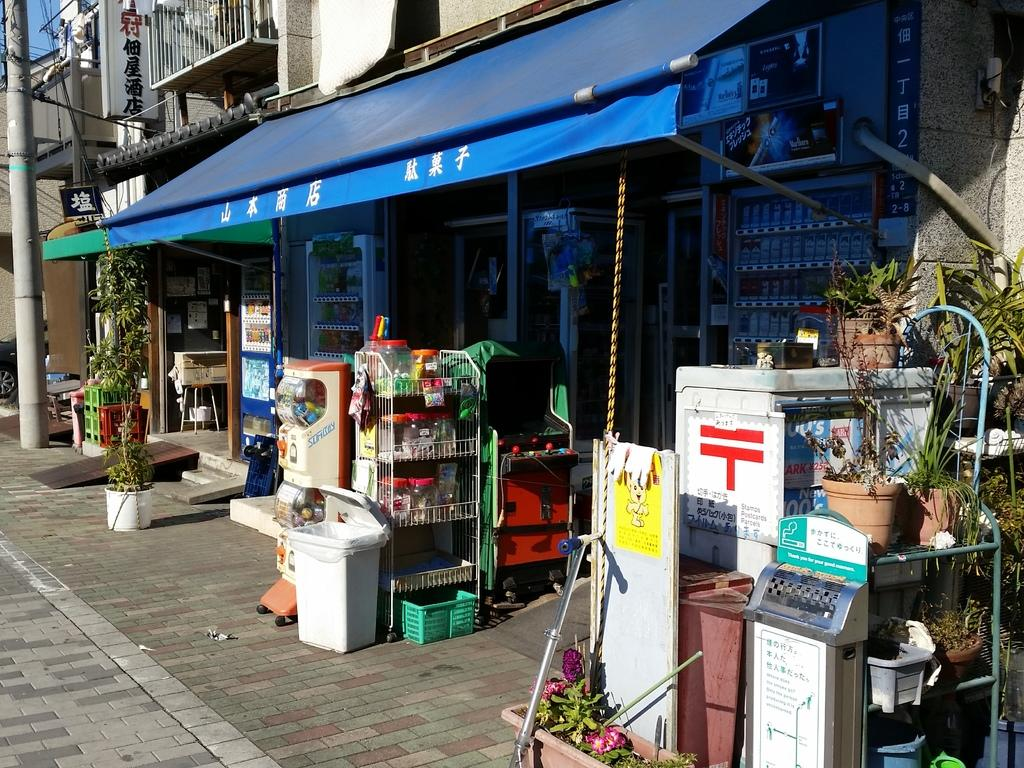<image>
Offer a succinct explanation of the picture presented. A storefront with a candy machine outside that says Sumboy on the side 